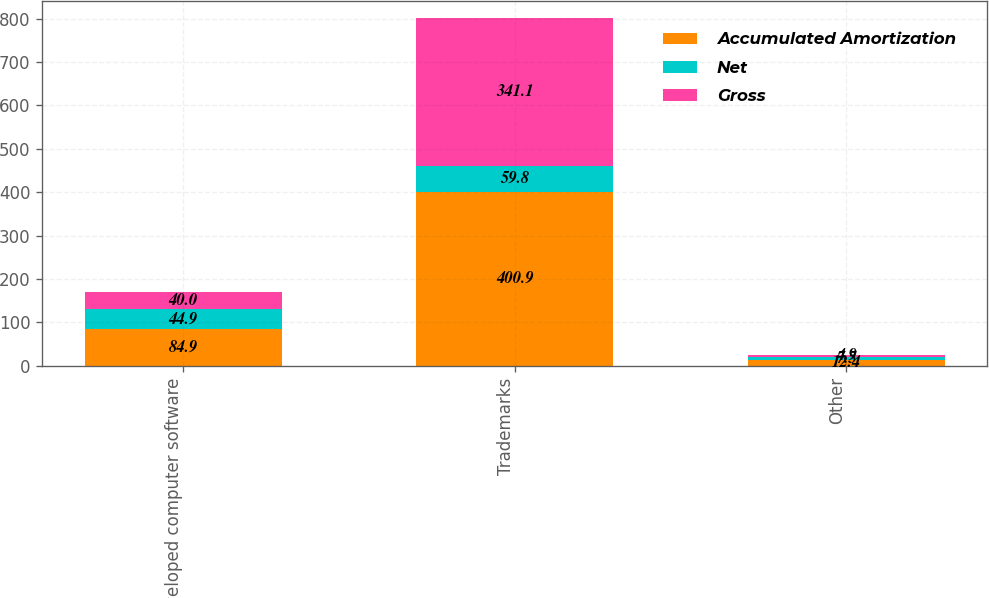<chart> <loc_0><loc_0><loc_500><loc_500><stacked_bar_chart><ecel><fcel>Developed computer software<fcel>Trademarks<fcel>Other<nl><fcel>Accumulated Amortization<fcel>84.9<fcel>400.9<fcel>12.4<nl><fcel>Net<fcel>44.9<fcel>59.8<fcel>7.5<nl><fcel>Gross<fcel>40<fcel>341.1<fcel>4.9<nl></chart> 